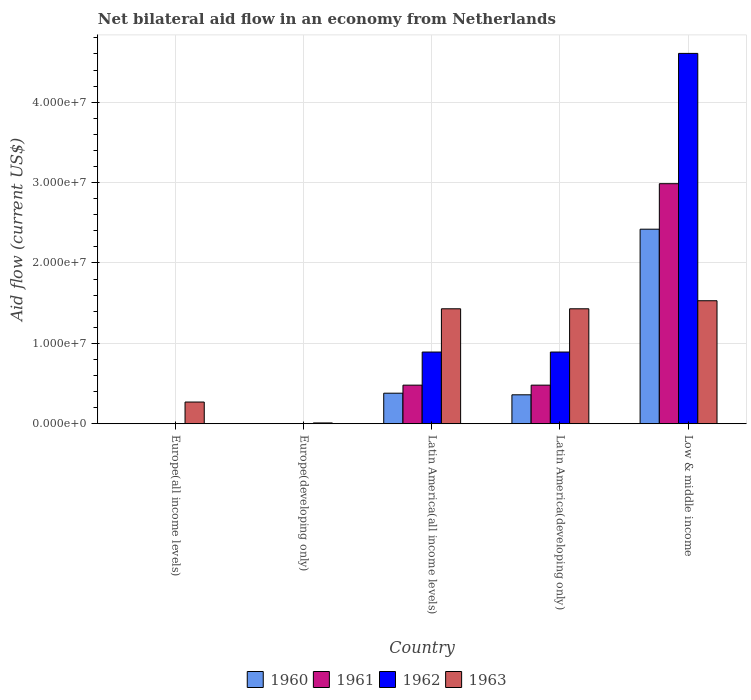How many different coloured bars are there?
Provide a short and direct response. 4. How many bars are there on the 4th tick from the left?
Offer a very short reply. 4. What is the label of the 1st group of bars from the left?
Offer a very short reply. Europe(all income levels). What is the net bilateral aid flow in 1960 in Latin America(developing only)?
Offer a terse response. 3.60e+06. Across all countries, what is the maximum net bilateral aid flow in 1961?
Offer a terse response. 2.99e+07. What is the total net bilateral aid flow in 1961 in the graph?
Keep it short and to the point. 3.95e+07. What is the difference between the net bilateral aid flow in 1963 in Europe(developing only) and that in Latin America(all income levels)?
Your response must be concise. -1.42e+07. What is the difference between the net bilateral aid flow in 1961 in Europe(all income levels) and the net bilateral aid flow in 1962 in Latin America(all income levels)?
Give a very brief answer. -8.92e+06. What is the average net bilateral aid flow in 1963 per country?
Give a very brief answer. 9.34e+06. What is the difference between the net bilateral aid flow of/in 1962 and net bilateral aid flow of/in 1963 in Latin America(all income levels)?
Make the answer very short. -5.38e+06. In how many countries, is the net bilateral aid flow in 1963 greater than 32000000 US$?
Offer a very short reply. 0. What is the ratio of the net bilateral aid flow in 1962 in Latin America(developing only) to that in Low & middle income?
Provide a short and direct response. 0.19. Is the net bilateral aid flow in 1962 in Latin America(all income levels) less than that in Low & middle income?
Make the answer very short. Yes. Is the difference between the net bilateral aid flow in 1962 in Latin America(all income levels) and Low & middle income greater than the difference between the net bilateral aid flow in 1963 in Latin America(all income levels) and Low & middle income?
Make the answer very short. No. What is the difference between the highest and the second highest net bilateral aid flow in 1961?
Provide a succinct answer. 2.51e+07. What is the difference between the highest and the lowest net bilateral aid flow in 1963?
Offer a very short reply. 1.52e+07. In how many countries, is the net bilateral aid flow in 1963 greater than the average net bilateral aid flow in 1963 taken over all countries?
Offer a terse response. 3. Is it the case that in every country, the sum of the net bilateral aid flow in 1961 and net bilateral aid flow in 1962 is greater than the net bilateral aid flow in 1960?
Provide a short and direct response. No. Are all the bars in the graph horizontal?
Offer a very short reply. No. Are the values on the major ticks of Y-axis written in scientific E-notation?
Make the answer very short. Yes. Does the graph contain grids?
Your answer should be compact. Yes. Where does the legend appear in the graph?
Ensure brevity in your answer.  Bottom center. How are the legend labels stacked?
Provide a short and direct response. Horizontal. What is the title of the graph?
Your response must be concise. Net bilateral aid flow in an economy from Netherlands. What is the Aid flow (current US$) of 1961 in Europe(all income levels)?
Your answer should be compact. 0. What is the Aid flow (current US$) in 1962 in Europe(all income levels)?
Ensure brevity in your answer.  0. What is the Aid flow (current US$) in 1963 in Europe(all income levels)?
Keep it short and to the point. 2.70e+06. What is the Aid flow (current US$) in 1960 in Europe(developing only)?
Offer a very short reply. 0. What is the Aid flow (current US$) in 1961 in Europe(developing only)?
Your response must be concise. 0. What is the Aid flow (current US$) of 1960 in Latin America(all income levels)?
Make the answer very short. 3.80e+06. What is the Aid flow (current US$) in 1961 in Latin America(all income levels)?
Your response must be concise. 4.80e+06. What is the Aid flow (current US$) in 1962 in Latin America(all income levels)?
Make the answer very short. 8.92e+06. What is the Aid flow (current US$) of 1963 in Latin America(all income levels)?
Provide a succinct answer. 1.43e+07. What is the Aid flow (current US$) in 1960 in Latin America(developing only)?
Give a very brief answer. 3.60e+06. What is the Aid flow (current US$) in 1961 in Latin America(developing only)?
Provide a succinct answer. 4.80e+06. What is the Aid flow (current US$) in 1962 in Latin America(developing only)?
Offer a terse response. 8.92e+06. What is the Aid flow (current US$) in 1963 in Latin America(developing only)?
Your answer should be compact. 1.43e+07. What is the Aid flow (current US$) in 1960 in Low & middle income?
Keep it short and to the point. 2.42e+07. What is the Aid flow (current US$) of 1961 in Low & middle income?
Give a very brief answer. 2.99e+07. What is the Aid flow (current US$) in 1962 in Low & middle income?
Offer a very short reply. 4.61e+07. What is the Aid flow (current US$) in 1963 in Low & middle income?
Keep it short and to the point. 1.53e+07. Across all countries, what is the maximum Aid flow (current US$) of 1960?
Offer a very short reply. 2.42e+07. Across all countries, what is the maximum Aid flow (current US$) in 1961?
Your response must be concise. 2.99e+07. Across all countries, what is the maximum Aid flow (current US$) in 1962?
Offer a terse response. 4.61e+07. Across all countries, what is the maximum Aid flow (current US$) of 1963?
Offer a very short reply. 1.53e+07. Across all countries, what is the minimum Aid flow (current US$) in 1960?
Make the answer very short. 0. Across all countries, what is the minimum Aid flow (current US$) of 1963?
Offer a terse response. 1.00e+05. What is the total Aid flow (current US$) in 1960 in the graph?
Ensure brevity in your answer.  3.16e+07. What is the total Aid flow (current US$) in 1961 in the graph?
Provide a short and direct response. 3.95e+07. What is the total Aid flow (current US$) in 1962 in the graph?
Your response must be concise. 6.39e+07. What is the total Aid flow (current US$) of 1963 in the graph?
Keep it short and to the point. 4.67e+07. What is the difference between the Aid flow (current US$) of 1963 in Europe(all income levels) and that in Europe(developing only)?
Give a very brief answer. 2.60e+06. What is the difference between the Aid flow (current US$) in 1963 in Europe(all income levels) and that in Latin America(all income levels)?
Your response must be concise. -1.16e+07. What is the difference between the Aid flow (current US$) of 1963 in Europe(all income levels) and that in Latin America(developing only)?
Offer a terse response. -1.16e+07. What is the difference between the Aid flow (current US$) of 1963 in Europe(all income levels) and that in Low & middle income?
Ensure brevity in your answer.  -1.26e+07. What is the difference between the Aid flow (current US$) in 1963 in Europe(developing only) and that in Latin America(all income levels)?
Your answer should be very brief. -1.42e+07. What is the difference between the Aid flow (current US$) in 1963 in Europe(developing only) and that in Latin America(developing only)?
Your response must be concise. -1.42e+07. What is the difference between the Aid flow (current US$) in 1963 in Europe(developing only) and that in Low & middle income?
Provide a short and direct response. -1.52e+07. What is the difference between the Aid flow (current US$) of 1960 in Latin America(all income levels) and that in Latin America(developing only)?
Your answer should be compact. 2.00e+05. What is the difference between the Aid flow (current US$) of 1961 in Latin America(all income levels) and that in Latin America(developing only)?
Your answer should be compact. 0. What is the difference between the Aid flow (current US$) in 1963 in Latin America(all income levels) and that in Latin America(developing only)?
Your answer should be compact. 0. What is the difference between the Aid flow (current US$) in 1960 in Latin America(all income levels) and that in Low & middle income?
Keep it short and to the point. -2.04e+07. What is the difference between the Aid flow (current US$) in 1961 in Latin America(all income levels) and that in Low & middle income?
Offer a very short reply. -2.51e+07. What is the difference between the Aid flow (current US$) in 1962 in Latin America(all income levels) and that in Low & middle income?
Provide a succinct answer. -3.72e+07. What is the difference between the Aid flow (current US$) of 1960 in Latin America(developing only) and that in Low & middle income?
Your answer should be compact. -2.06e+07. What is the difference between the Aid flow (current US$) of 1961 in Latin America(developing only) and that in Low & middle income?
Offer a very short reply. -2.51e+07. What is the difference between the Aid flow (current US$) in 1962 in Latin America(developing only) and that in Low & middle income?
Provide a short and direct response. -3.72e+07. What is the difference between the Aid flow (current US$) of 1960 in Latin America(all income levels) and the Aid flow (current US$) of 1962 in Latin America(developing only)?
Offer a terse response. -5.12e+06. What is the difference between the Aid flow (current US$) of 1960 in Latin America(all income levels) and the Aid flow (current US$) of 1963 in Latin America(developing only)?
Provide a short and direct response. -1.05e+07. What is the difference between the Aid flow (current US$) of 1961 in Latin America(all income levels) and the Aid flow (current US$) of 1962 in Latin America(developing only)?
Give a very brief answer. -4.12e+06. What is the difference between the Aid flow (current US$) in 1961 in Latin America(all income levels) and the Aid flow (current US$) in 1963 in Latin America(developing only)?
Keep it short and to the point. -9.50e+06. What is the difference between the Aid flow (current US$) of 1962 in Latin America(all income levels) and the Aid flow (current US$) of 1963 in Latin America(developing only)?
Keep it short and to the point. -5.38e+06. What is the difference between the Aid flow (current US$) in 1960 in Latin America(all income levels) and the Aid flow (current US$) in 1961 in Low & middle income?
Ensure brevity in your answer.  -2.61e+07. What is the difference between the Aid flow (current US$) of 1960 in Latin America(all income levels) and the Aid flow (current US$) of 1962 in Low & middle income?
Offer a very short reply. -4.23e+07. What is the difference between the Aid flow (current US$) of 1960 in Latin America(all income levels) and the Aid flow (current US$) of 1963 in Low & middle income?
Give a very brief answer. -1.15e+07. What is the difference between the Aid flow (current US$) of 1961 in Latin America(all income levels) and the Aid flow (current US$) of 1962 in Low & middle income?
Provide a succinct answer. -4.13e+07. What is the difference between the Aid flow (current US$) in 1961 in Latin America(all income levels) and the Aid flow (current US$) in 1963 in Low & middle income?
Offer a terse response. -1.05e+07. What is the difference between the Aid flow (current US$) of 1962 in Latin America(all income levels) and the Aid flow (current US$) of 1963 in Low & middle income?
Ensure brevity in your answer.  -6.38e+06. What is the difference between the Aid flow (current US$) in 1960 in Latin America(developing only) and the Aid flow (current US$) in 1961 in Low & middle income?
Give a very brief answer. -2.63e+07. What is the difference between the Aid flow (current US$) of 1960 in Latin America(developing only) and the Aid flow (current US$) of 1962 in Low & middle income?
Your answer should be very brief. -4.25e+07. What is the difference between the Aid flow (current US$) of 1960 in Latin America(developing only) and the Aid flow (current US$) of 1963 in Low & middle income?
Your answer should be compact. -1.17e+07. What is the difference between the Aid flow (current US$) of 1961 in Latin America(developing only) and the Aid flow (current US$) of 1962 in Low & middle income?
Offer a very short reply. -4.13e+07. What is the difference between the Aid flow (current US$) in 1961 in Latin America(developing only) and the Aid flow (current US$) in 1963 in Low & middle income?
Offer a terse response. -1.05e+07. What is the difference between the Aid flow (current US$) in 1962 in Latin America(developing only) and the Aid flow (current US$) in 1963 in Low & middle income?
Provide a succinct answer. -6.38e+06. What is the average Aid flow (current US$) in 1960 per country?
Make the answer very short. 6.32e+06. What is the average Aid flow (current US$) of 1961 per country?
Your response must be concise. 7.89e+06. What is the average Aid flow (current US$) in 1962 per country?
Provide a short and direct response. 1.28e+07. What is the average Aid flow (current US$) of 1963 per country?
Give a very brief answer. 9.34e+06. What is the difference between the Aid flow (current US$) of 1960 and Aid flow (current US$) of 1962 in Latin America(all income levels)?
Offer a very short reply. -5.12e+06. What is the difference between the Aid flow (current US$) in 1960 and Aid flow (current US$) in 1963 in Latin America(all income levels)?
Provide a short and direct response. -1.05e+07. What is the difference between the Aid flow (current US$) of 1961 and Aid flow (current US$) of 1962 in Latin America(all income levels)?
Your answer should be very brief. -4.12e+06. What is the difference between the Aid flow (current US$) in 1961 and Aid flow (current US$) in 1963 in Latin America(all income levels)?
Make the answer very short. -9.50e+06. What is the difference between the Aid flow (current US$) of 1962 and Aid flow (current US$) of 1963 in Latin America(all income levels)?
Ensure brevity in your answer.  -5.38e+06. What is the difference between the Aid flow (current US$) of 1960 and Aid flow (current US$) of 1961 in Latin America(developing only)?
Make the answer very short. -1.20e+06. What is the difference between the Aid flow (current US$) in 1960 and Aid flow (current US$) in 1962 in Latin America(developing only)?
Make the answer very short. -5.32e+06. What is the difference between the Aid flow (current US$) in 1960 and Aid flow (current US$) in 1963 in Latin America(developing only)?
Offer a terse response. -1.07e+07. What is the difference between the Aid flow (current US$) in 1961 and Aid flow (current US$) in 1962 in Latin America(developing only)?
Offer a terse response. -4.12e+06. What is the difference between the Aid flow (current US$) in 1961 and Aid flow (current US$) in 1963 in Latin America(developing only)?
Provide a short and direct response. -9.50e+06. What is the difference between the Aid flow (current US$) in 1962 and Aid flow (current US$) in 1963 in Latin America(developing only)?
Make the answer very short. -5.38e+06. What is the difference between the Aid flow (current US$) in 1960 and Aid flow (current US$) in 1961 in Low & middle income?
Keep it short and to the point. -5.66e+06. What is the difference between the Aid flow (current US$) in 1960 and Aid flow (current US$) in 1962 in Low & middle income?
Provide a short and direct response. -2.19e+07. What is the difference between the Aid flow (current US$) of 1960 and Aid flow (current US$) of 1963 in Low & middle income?
Your response must be concise. 8.90e+06. What is the difference between the Aid flow (current US$) of 1961 and Aid flow (current US$) of 1962 in Low & middle income?
Your answer should be compact. -1.62e+07. What is the difference between the Aid flow (current US$) of 1961 and Aid flow (current US$) of 1963 in Low & middle income?
Make the answer very short. 1.46e+07. What is the difference between the Aid flow (current US$) of 1962 and Aid flow (current US$) of 1963 in Low & middle income?
Give a very brief answer. 3.08e+07. What is the ratio of the Aid flow (current US$) of 1963 in Europe(all income levels) to that in Europe(developing only)?
Give a very brief answer. 27. What is the ratio of the Aid flow (current US$) of 1963 in Europe(all income levels) to that in Latin America(all income levels)?
Make the answer very short. 0.19. What is the ratio of the Aid flow (current US$) of 1963 in Europe(all income levels) to that in Latin America(developing only)?
Offer a terse response. 0.19. What is the ratio of the Aid flow (current US$) of 1963 in Europe(all income levels) to that in Low & middle income?
Your answer should be compact. 0.18. What is the ratio of the Aid flow (current US$) in 1963 in Europe(developing only) to that in Latin America(all income levels)?
Your response must be concise. 0.01. What is the ratio of the Aid flow (current US$) in 1963 in Europe(developing only) to that in Latin America(developing only)?
Your answer should be compact. 0.01. What is the ratio of the Aid flow (current US$) of 1963 in Europe(developing only) to that in Low & middle income?
Your response must be concise. 0.01. What is the ratio of the Aid flow (current US$) of 1960 in Latin America(all income levels) to that in Latin America(developing only)?
Offer a very short reply. 1.06. What is the ratio of the Aid flow (current US$) of 1960 in Latin America(all income levels) to that in Low & middle income?
Your response must be concise. 0.16. What is the ratio of the Aid flow (current US$) of 1961 in Latin America(all income levels) to that in Low & middle income?
Your answer should be very brief. 0.16. What is the ratio of the Aid flow (current US$) of 1962 in Latin America(all income levels) to that in Low & middle income?
Offer a terse response. 0.19. What is the ratio of the Aid flow (current US$) in 1963 in Latin America(all income levels) to that in Low & middle income?
Make the answer very short. 0.93. What is the ratio of the Aid flow (current US$) of 1960 in Latin America(developing only) to that in Low & middle income?
Provide a short and direct response. 0.15. What is the ratio of the Aid flow (current US$) in 1961 in Latin America(developing only) to that in Low & middle income?
Offer a very short reply. 0.16. What is the ratio of the Aid flow (current US$) in 1962 in Latin America(developing only) to that in Low & middle income?
Offer a terse response. 0.19. What is the ratio of the Aid flow (current US$) in 1963 in Latin America(developing only) to that in Low & middle income?
Keep it short and to the point. 0.93. What is the difference between the highest and the second highest Aid flow (current US$) in 1960?
Your response must be concise. 2.04e+07. What is the difference between the highest and the second highest Aid flow (current US$) of 1961?
Offer a terse response. 2.51e+07. What is the difference between the highest and the second highest Aid flow (current US$) of 1962?
Ensure brevity in your answer.  3.72e+07. What is the difference between the highest and the second highest Aid flow (current US$) in 1963?
Make the answer very short. 1.00e+06. What is the difference between the highest and the lowest Aid flow (current US$) of 1960?
Ensure brevity in your answer.  2.42e+07. What is the difference between the highest and the lowest Aid flow (current US$) of 1961?
Your answer should be very brief. 2.99e+07. What is the difference between the highest and the lowest Aid flow (current US$) of 1962?
Provide a succinct answer. 4.61e+07. What is the difference between the highest and the lowest Aid flow (current US$) of 1963?
Make the answer very short. 1.52e+07. 